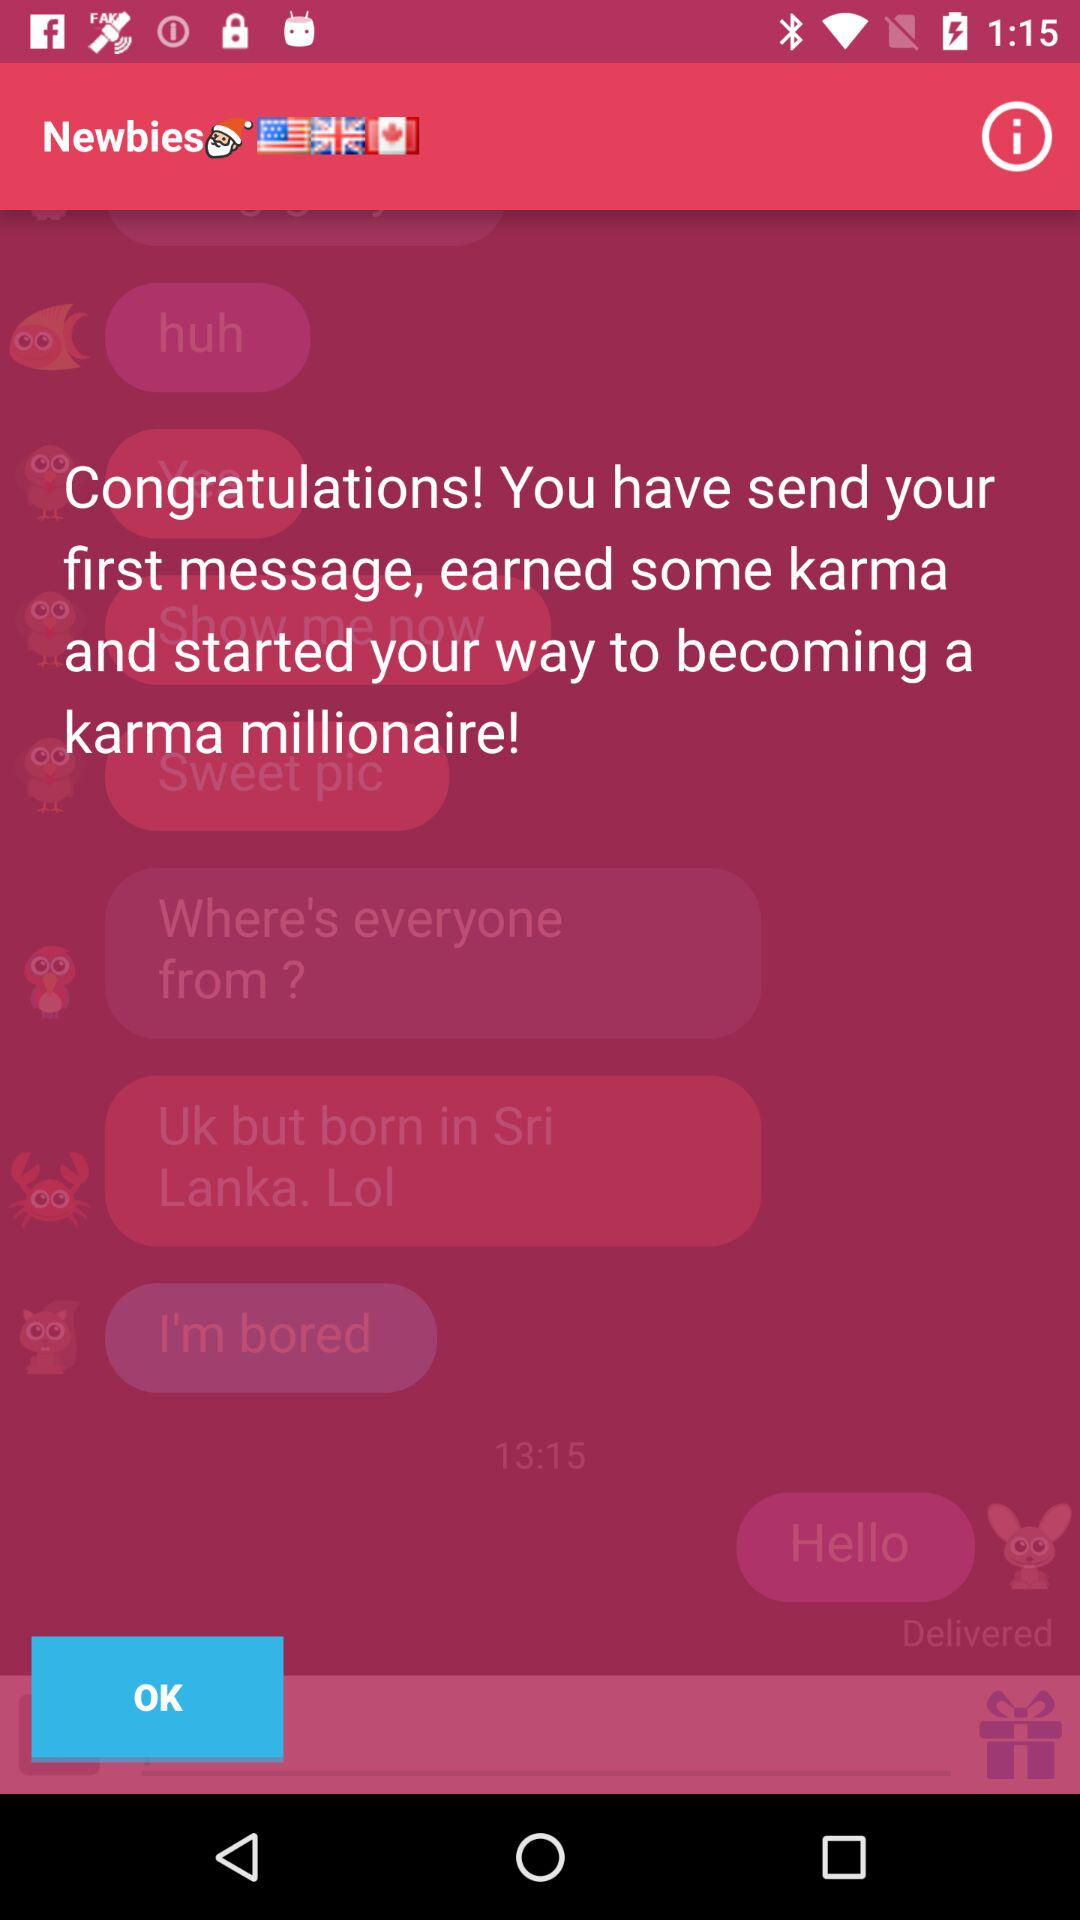What is the name of the application? The name of the application is "Newbies". 